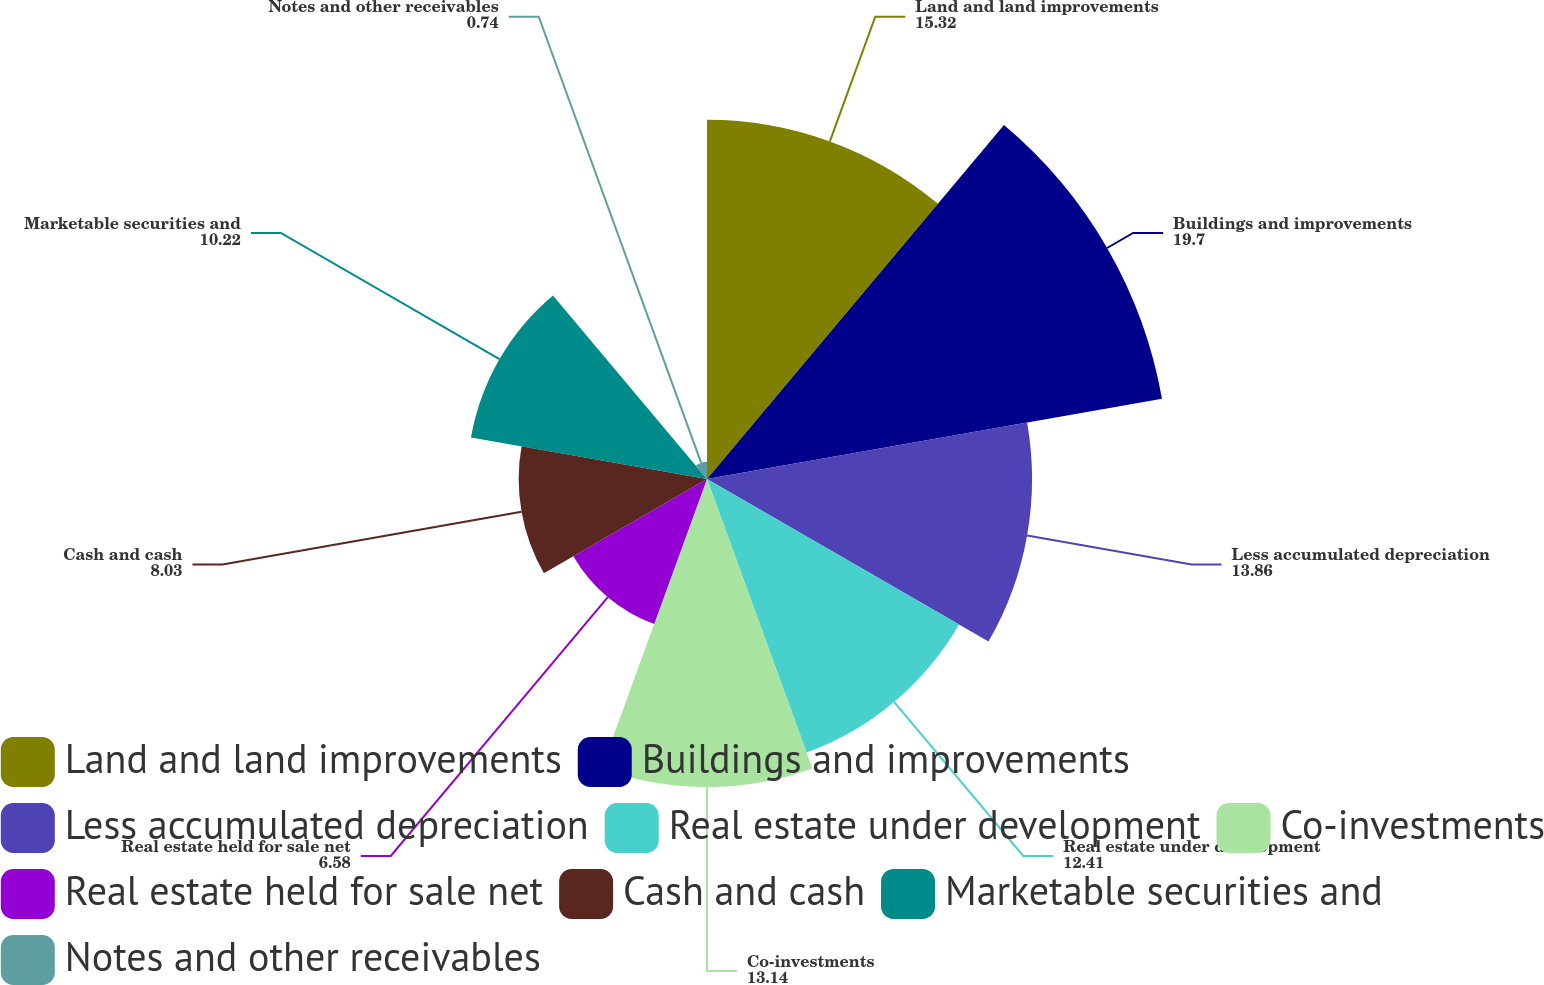Convert chart to OTSL. <chart><loc_0><loc_0><loc_500><loc_500><pie_chart><fcel>Land and land improvements<fcel>Buildings and improvements<fcel>Less accumulated depreciation<fcel>Real estate under development<fcel>Co-investments<fcel>Real estate held for sale net<fcel>Cash and cash<fcel>Marketable securities and<fcel>Notes and other receivables<nl><fcel>15.32%<fcel>19.7%<fcel>13.86%<fcel>12.41%<fcel>13.14%<fcel>6.58%<fcel>8.03%<fcel>10.22%<fcel>0.74%<nl></chart> 